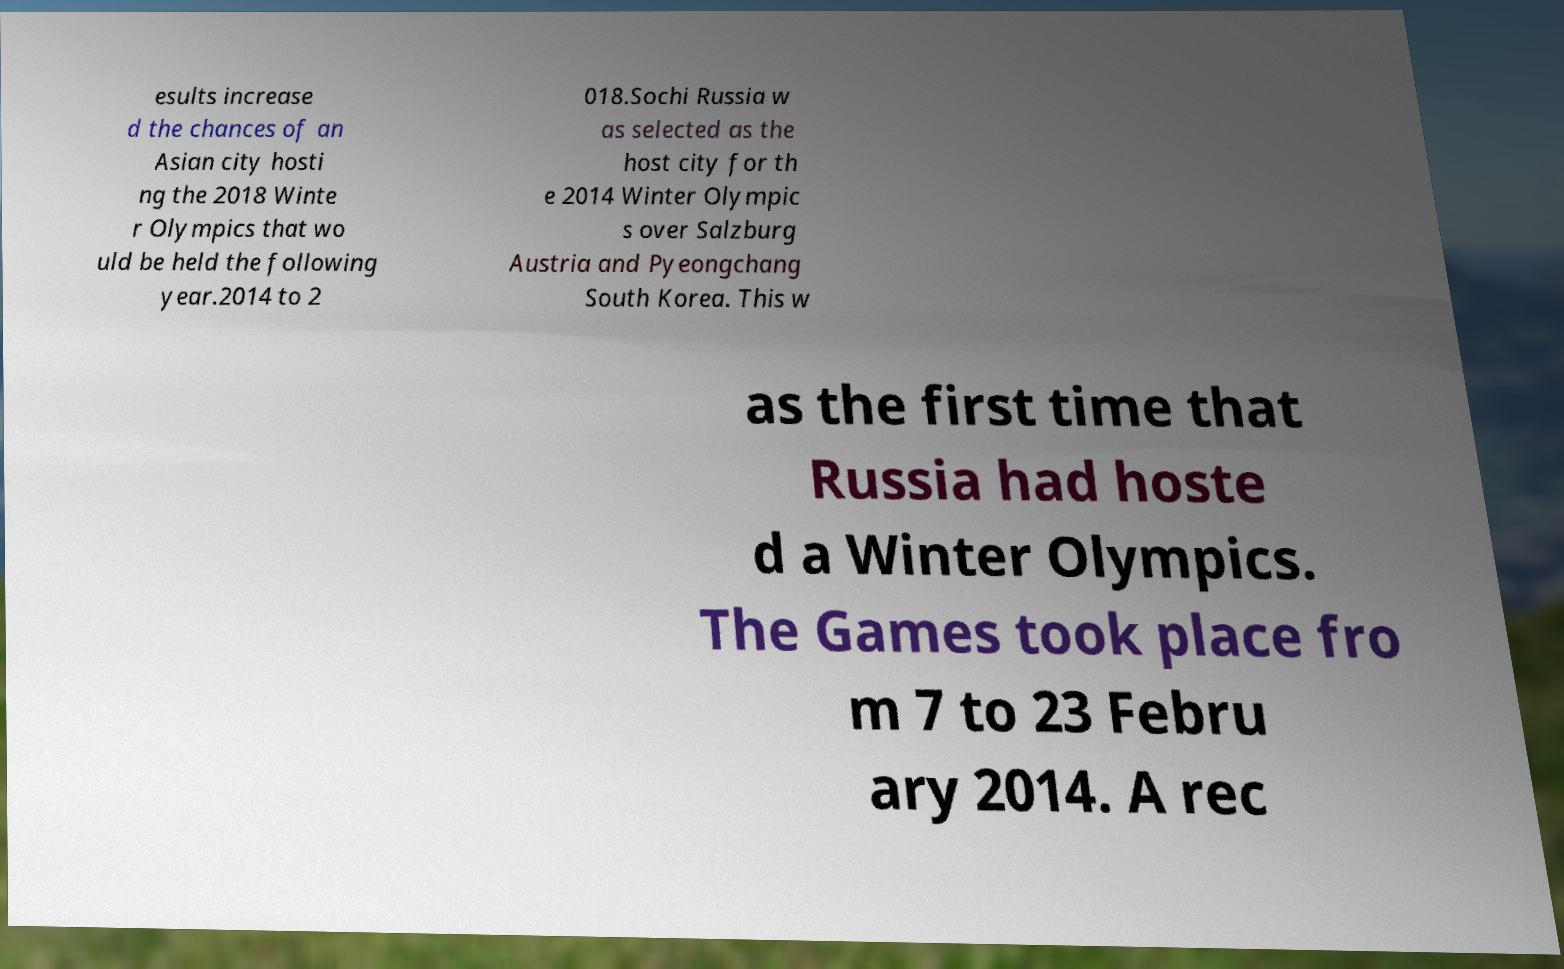Can you read and provide the text displayed in the image?This photo seems to have some interesting text. Can you extract and type it out for me? esults increase d the chances of an Asian city hosti ng the 2018 Winte r Olympics that wo uld be held the following year.2014 to 2 018.Sochi Russia w as selected as the host city for th e 2014 Winter Olympic s over Salzburg Austria and Pyeongchang South Korea. This w as the first time that Russia had hoste d a Winter Olympics. The Games took place fro m 7 to 23 Febru ary 2014. A rec 